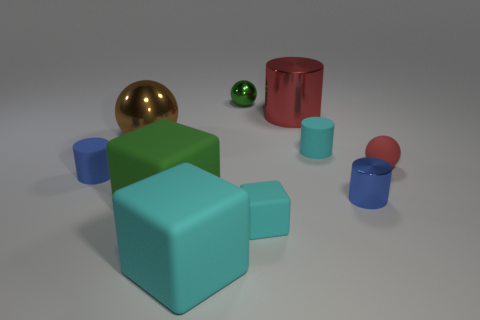Is the big cyan cube made of the same material as the green ball?
Your answer should be very brief. No. There is a matte thing left of the big brown ball; what number of metallic spheres are to the left of it?
Your answer should be compact. 0. There is a ball in front of the brown object; is its color the same as the large cylinder?
Provide a short and direct response. Yes. What number of objects are small green balls or small things in front of the small red thing?
Offer a terse response. 4. Is the shape of the blue object that is left of the large cyan matte object the same as the blue object right of the red cylinder?
Provide a succinct answer. Yes. Is there any other thing that has the same color as the large shiny ball?
Offer a terse response. No. There is another big object that is the same material as the big green object; what is its shape?
Your answer should be very brief. Cube. There is a sphere that is both to the right of the big brown sphere and left of the red rubber thing; what is it made of?
Provide a succinct answer. Metal. Does the tiny cube have the same color as the large metal cylinder?
Offer a terse response. No. What shape is the object that is the same color as the matte ball?
Your response must be concise. Cylinder. 